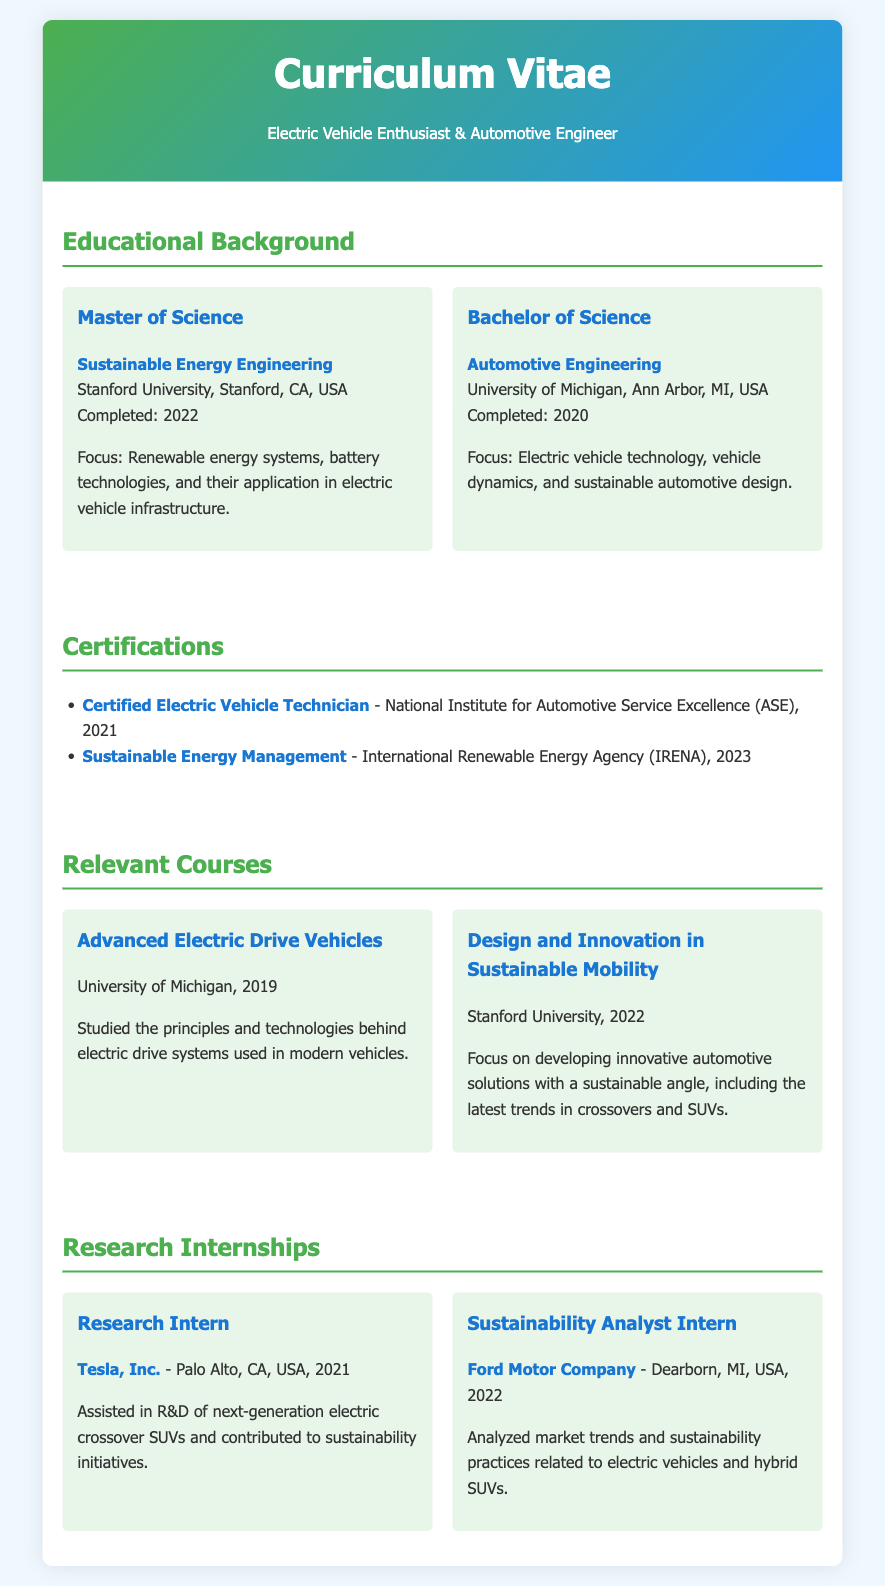what is the highest level of education obtained? The document indicates that the highest level of education is a Master of Science.
Answer: Master of Science where did the Bachelor of Science degree take place? The document states that the Bachelor of Science was completed at the University of Michigan.
Answer: University of Michigan when was the Master of Science degree completed? The document specifies that the Master of Science was completed in 2022.
Answer: 2022 what was the focus of the Bachelor's degree? According to the document, the focus of the Bachelor's degree was on electric vehicle technology, vehicle dynamics, and sustainable automotive design.
Answer: Electric vehicle technology, vehicle dynamics, and sustainable automotive design which company internship involved analyzing market trends? The document reveals that the internship at Ford Motor Company involved analyzing market trends.
Answer: Ford Motor Company how many certifications are listed in the document? The document contains two certifications listed.
Answer: Two what was the focus of the relevant course at Stanford University? The document states that the focus of the relevant course at Stanford University was on developing innovative automotive solutions with a sustainable angle.
Answer: Innovative automotive solutions with a sustainable angle what year did the Research Intern position take place at Tesla, Inc.? The document indicates that the Research Intern position at Tesla, Inc. took place in 2021.
Answer: 2021 what type of engineering is the Master’s degree in? The document specifies that the Master's degree is in Sustainable Energy Engineering.
Answer: Sustainable Energy Engineering 